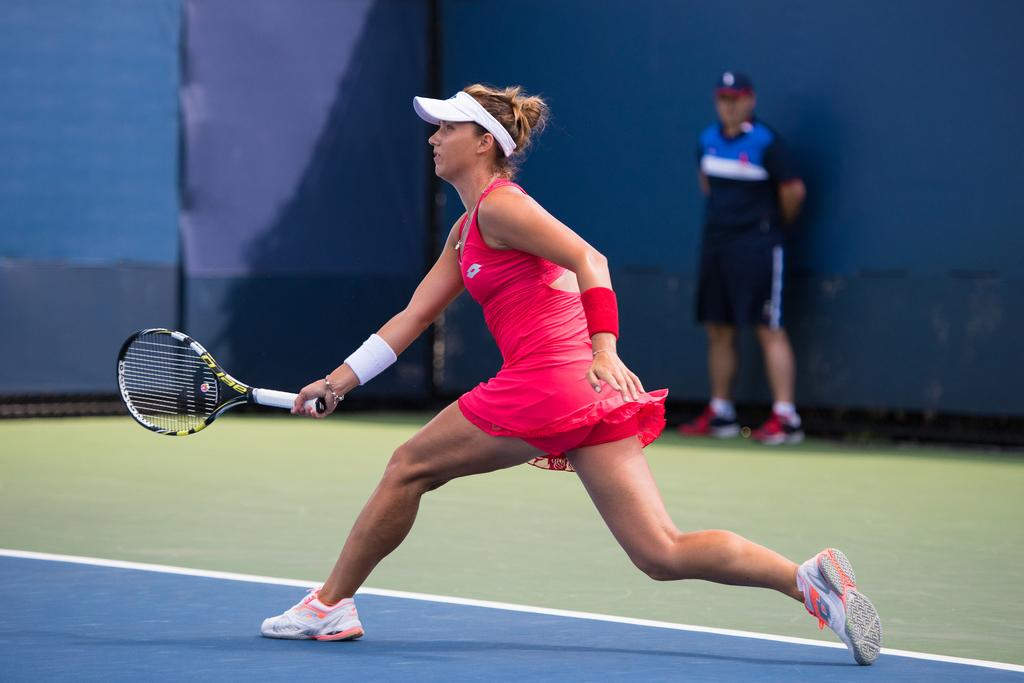Who is the main subject in the image? There is a woman in the image. What is the woman doing in the image? The woman is in motion, and she is holding a racket. What is the woman wearing on her head? The woman is wearing a cap. Can you describe the background of the image? The background is blue in color. Is there anyone else in the image besides the woman? Yes, there is a man standing in the background of the image. What type of cave can be seen in the background of the image? There is no cave present in the image; the background is blue in color. 